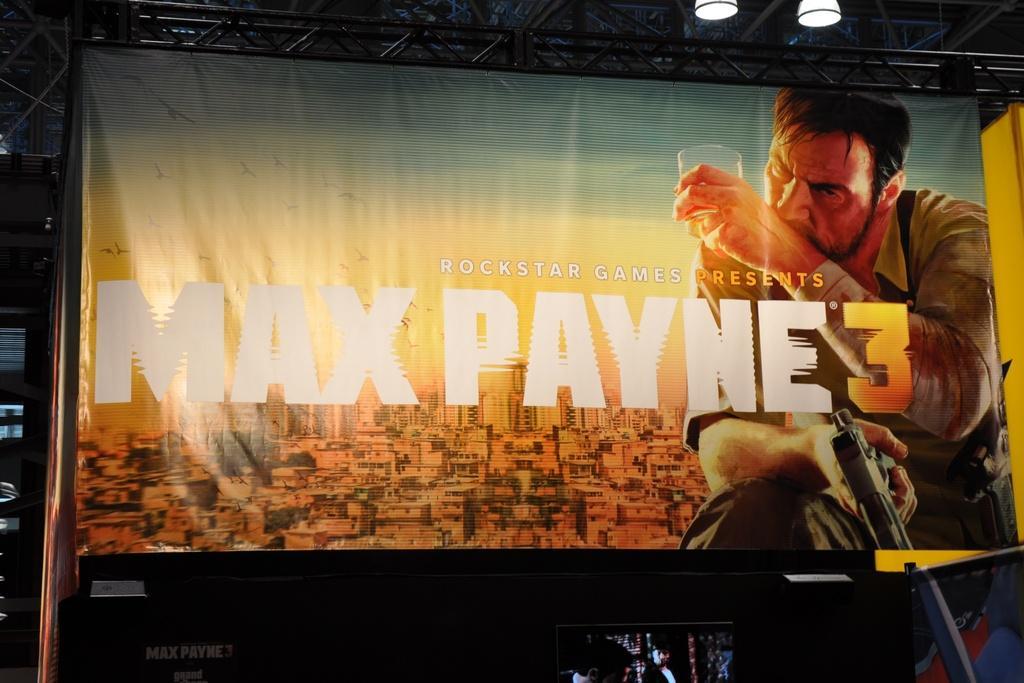In one or two sentences, can you explain what this image depicts? In this image we can see big poster. On the poster, we can see a man holding glass and gun, some text and buildings. At the bottom of the image, we can see a monitor and some objects. There are lights and metal pole at the top of the image. 